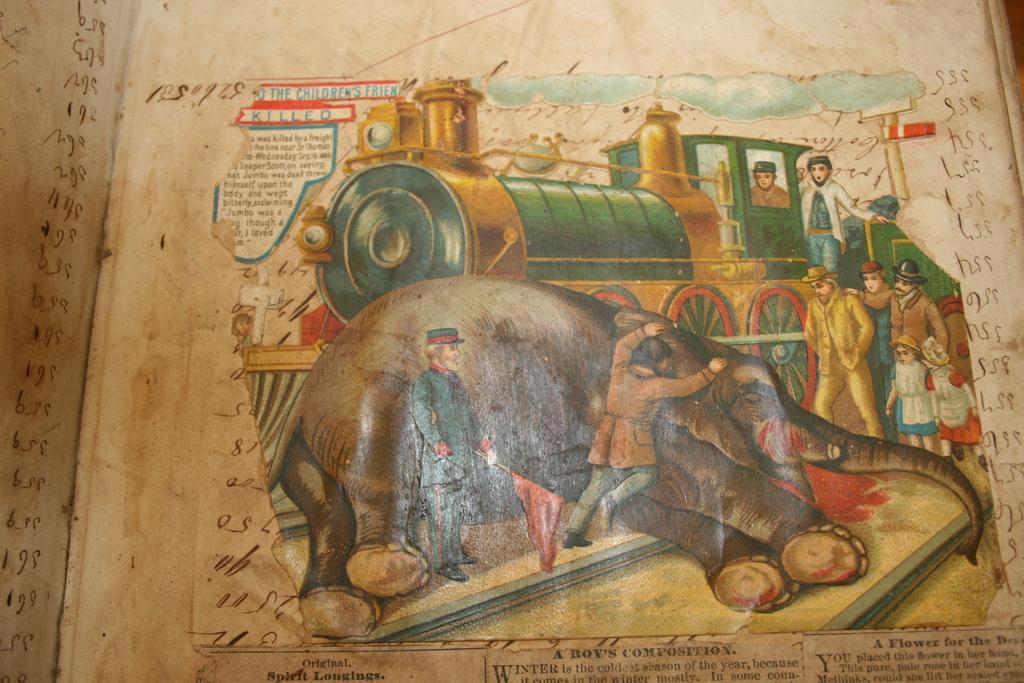Whose composition is this?
Offer a terse response. A boy's. What happened to the children's friend according to the tect?
Your response must be concise. Killed. 